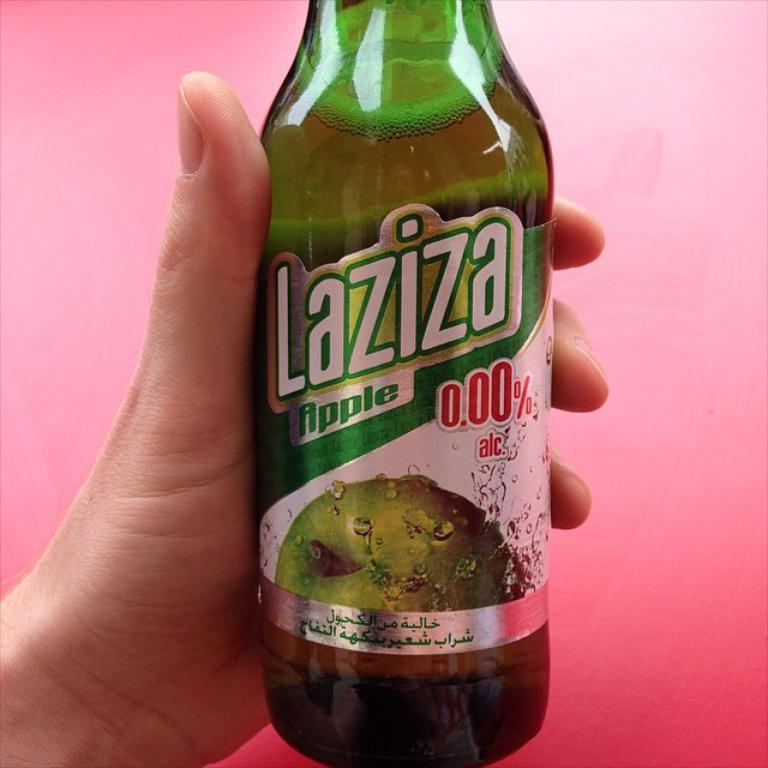What object can be seen in the image? There is a bottle in the image. Can you describe the interaction between the person and the bottle? It appears that a person is holding the bottle. What type of cable is being used by the farmer in the image? There is no farmer or cable present in the image; it only features a person holding a bottle. 